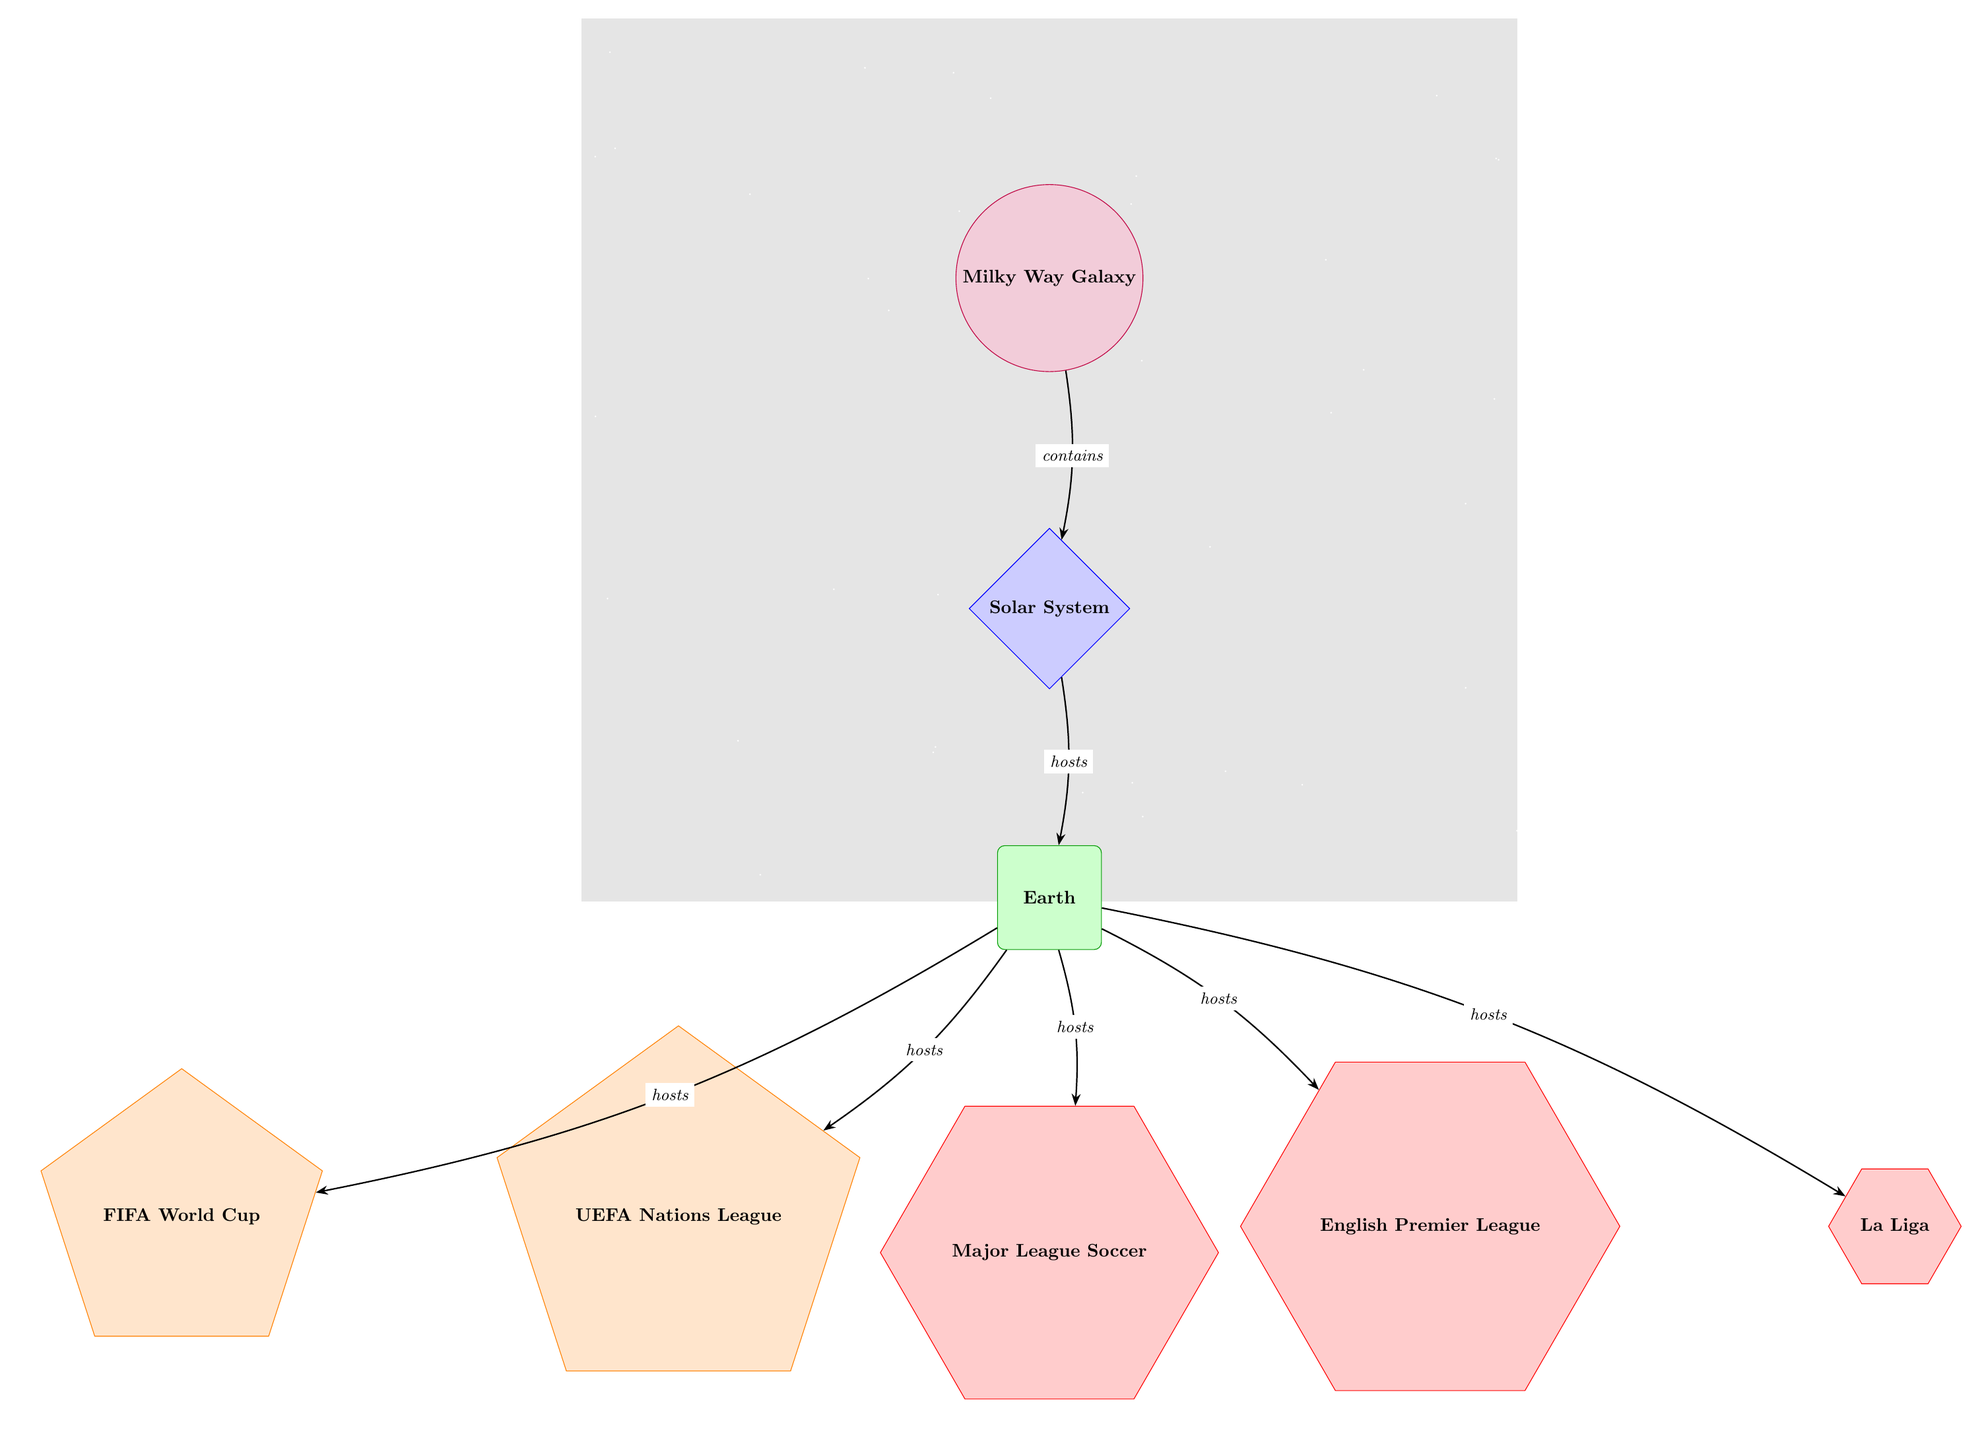What is the top-level object in the diagram? The diagram starts with the Milky Way Galaxy as the primary node. There are no other nodes positioned above it or connected in a hierarchical sense.
Answer: Milky Way Galaxy How many competitions are hosted on Earth? The diagram shows four competitions (UEFA Nations League, FIFA World Cup, English Premier League, La Liga, Major League Soccer) stemming directly from the Earth node, indicating the number of competitions hosted.
Answer: 5 What type of object is La Liga? According to the diagram, La Liga is represented as a regular polygon (specifically a hexagon) indicating it belongs to the category defined for leagues. Hence, it fits the criteria for being categorized under leagues.
Answer: league Which node connects the Solar System to Earth? The Solar System node is directly connected to the Earth node with an edge labeled as "hosts," indicating that the Solar System is the location that contains the Earth.
Answer: Earth Which competition is highlighted as being associated with the FIFA World Cup? The FIFA World Cup is directly mentioned as one of the competitions hosted on Earth. Although no additional associations are made in this diagram, it is among the relevant competitions that Earth is said to host.
Answer: FIFA World Cup Which league directly follows the English Premier League in the diagram? Based on the layout of the nodes, La Liga is positioned immediately to the right of the English Premier League node indicating its placement in relation to other leagues and competitions.
Answer: La Liga What is the primary relationship depicted between the Milky Way Galaxy and the Solar System? The Milky Way Galaxy contains the Solar System as indicated by the labeled edge connecting them in the diagram. This evidences the broader to specific relationship found within the structure of the diagram.
Answer: contains How are the MLS and Premier League categorized in this diagram? Both the MLS and Premier League are categorized as leagues, identifiable by their hexagonal shape in the diagram and their positioning as two of the objects stemming from the Earth node.
Answer: leagues 